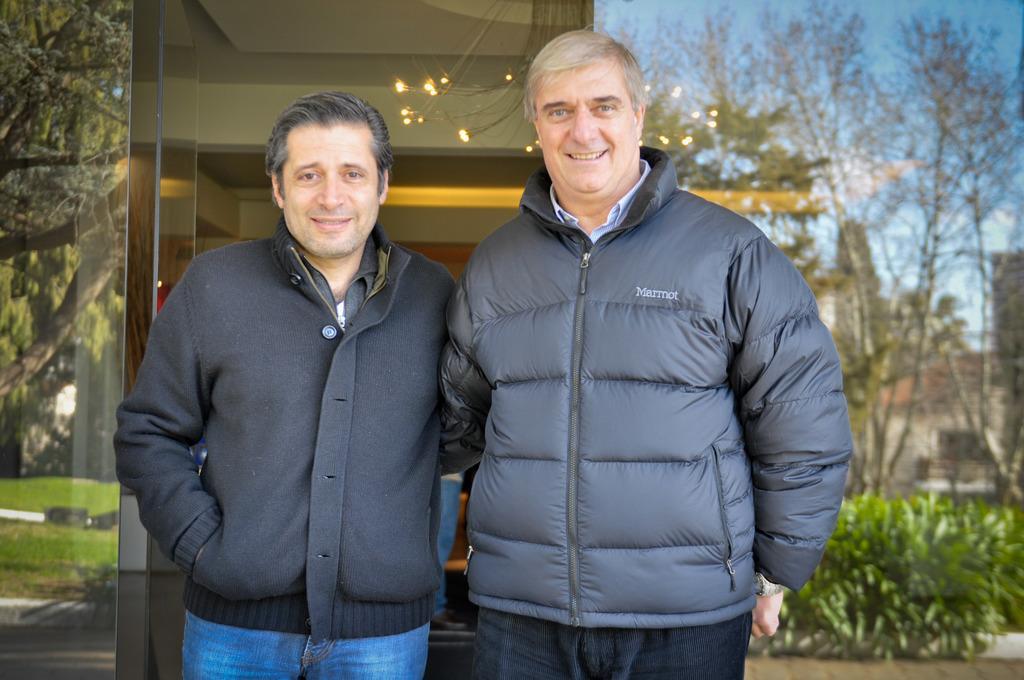How would you summarize this image in a sentence or two? In this picture there are two persons standing and smiling. At the back there are lights inside the building. There is a reflection of trees, plants, buildings, sky and clouds on the building. 